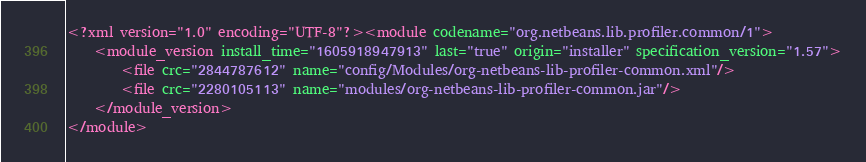Convert code to text. <code><loc_0><loc_0><loc_500><loc_500><_XML_><?xml version="1.0" encoding="UTF-8"?><module codename="org.netbeans.lib.profiler.common/1">
    <module_version install_time="1605918947913" last="true" origin="installer" specification_version="1.57">
        <file crc="2844787612" name="config/Modules/org-netbeans-lib-profiler-common.xml"/>
        <file crc="2280105113" name="modules/org-netbeans-lib-profiler-common.jar"/>
    </module_version>
</module>
</code> 